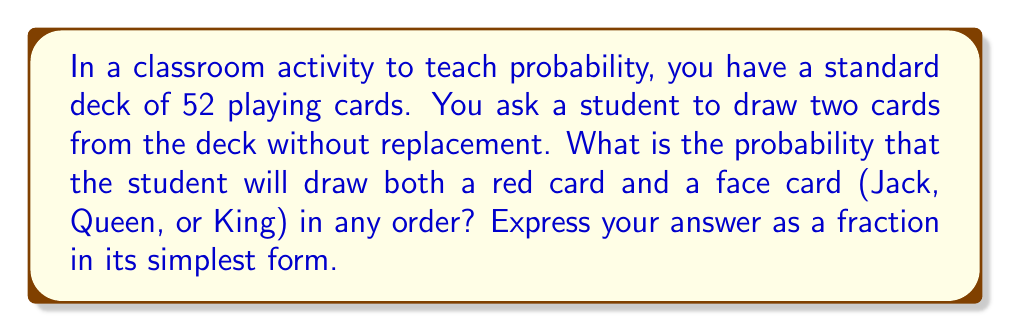Teach me how to tackle this problem. Let's approach this step-by-step:

1) First, we need to understand the composition of a standard deck:
   - 52 cards total
   - 26 red cards (13 hearts + 13 diamonds)
   - 12 face cards (3 each in hearts, diamonds, spades, and clubs)
   - 6 red face cards (3 in hearts + 3 in diamonds)

2) We can solve this problem by considering two scenarios:
   a) Drawing a red card first, then a face card
   b) Drawing a face card first, then a red card

3) Scenario a:
   - Probability of drawing a red card first: $\frac{26}{52} = \frac{1}{2}$
   - Probability of drawing a face card second: $\frac{12}{51}$
   - Probability of this scenario: $\frac{1}{2} \cdot \frac{12}{51} = \frac{12}{102}$

4) Scenario b:
   - Probability of drawing a face card first: $\frac{12}{52} = \frac{3}{13}$
   - Probability of drawing a red card second: $\frac{26}{51}$
   - Probability of this scenario: $\frac{3}{13} \cdot \frac{26}{51} = \frac{78}{663}$

5) The total probability is the sum of these two scenarios:
   $\frac{12}{102} + \frac{78}{663} = \frac{78}{663} + \frac{12}{102} = \frac{78}{663} + \frac{78}{663} = \frac{156}{663}$

6) Simplify the fraction:
   $\frac{156}{663} = \frac{52}{221}$

Thus, the probability of drawing both a red card and a face card in any order is $\frac{52}{221}$.
Answer: $\frac{52}{221}$ 